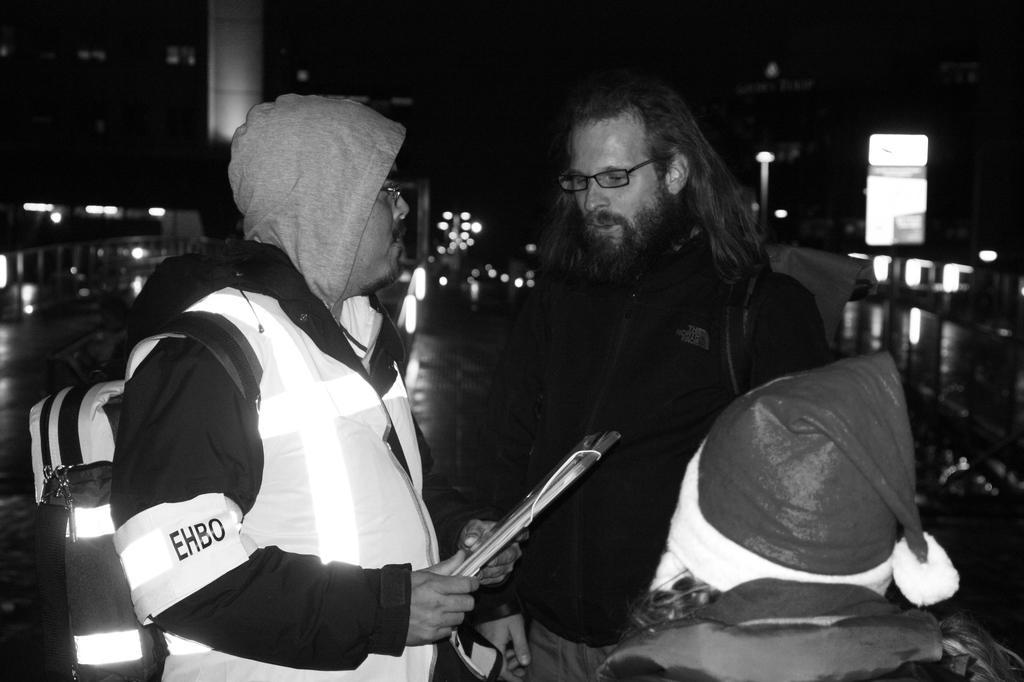Describe this image in one or two sentences. There are some persons standing as we can see in the middle of this image. The person standing on the left side is wearing a white color dress and holding a file. 